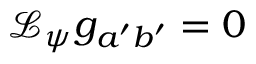Convert formula to latex. <formula><loc_0><loc_0><loc_500><loc_500>\mathcal { L } _ { \psi } g _ { a ^ { \prime } b ^ { \prime } } = 0</formula> 